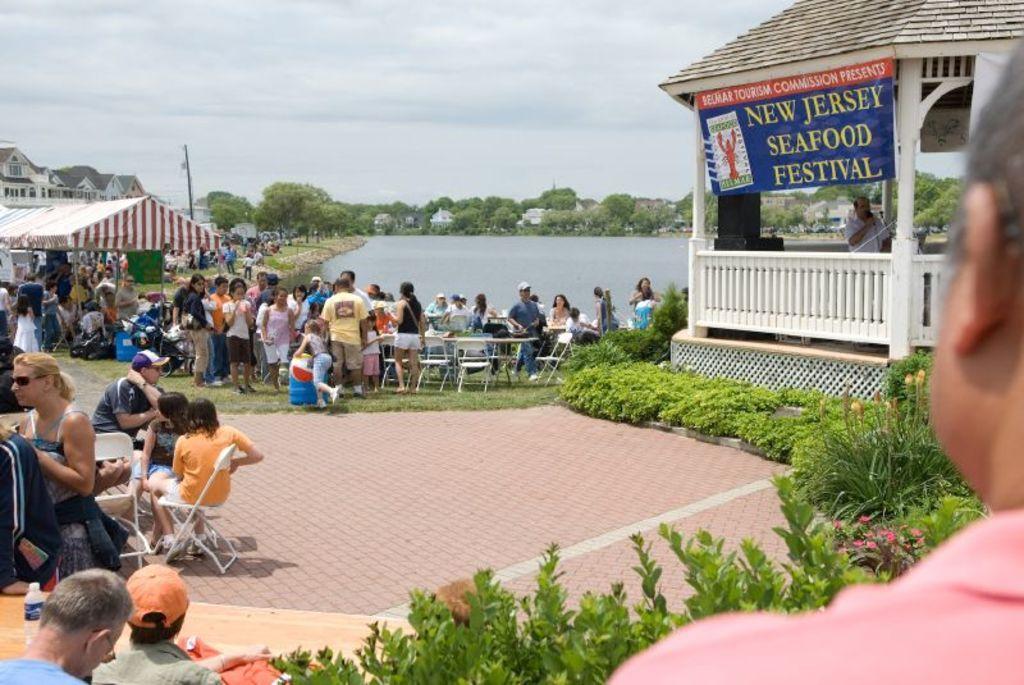In one or two sentences, can you explain what this image depicts? In this image I can see number of people where few are sitting on chairs and rest all are standing. In the background I can see a tent, few buildings, number of trees, clouds, the sky and here I can see something is written. 